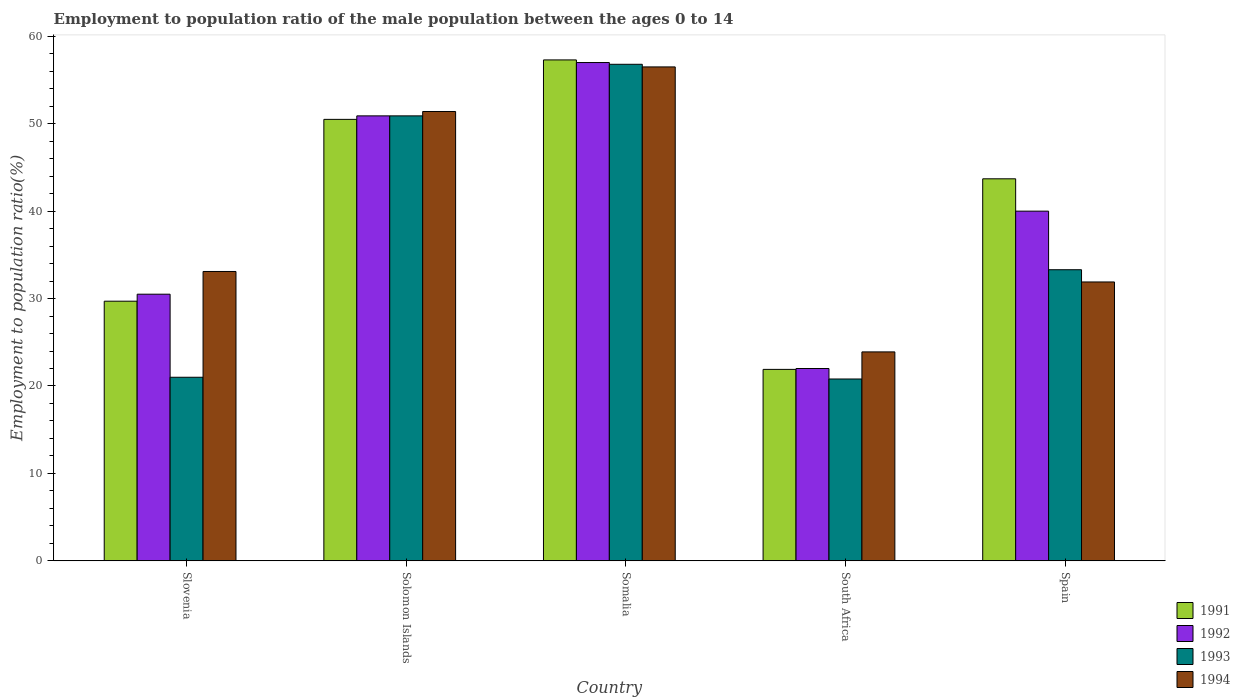How many groups of bars are there?
Provide a short and direct response. 5. Are the number of bars on each tick of the X-axis equal?
Your answer should be compact. Yes. How many bars are there on the 4th tick from the left?
Ensure brevity in your answer.  4. How many bars are there on the 2nd tick from the right?
Offer a terse response. 4. What is the employment to population ratio in 1991 in Spain?
Provide a short and direct response. 43.7. Across all countries, what is the maximum employment to population ratio in 1993?
Provide a succinct answer. 56.8. Across all countries, what is the minimum employment to population ratio in 1994?
Offer a terse response. 23.9. In which country was the employment to population ratio in 1992 maximum?
Provide a short and direct response. Somalia. In which country was the employment to population ratio in 1991 minimum?
Offer a very short reply. South Africa. What is the total employment to population ratio in 1994 in the graph?
Give a very brief answer. 196.8. What is the difference between the employment to population ratio in 1994 in Slovenia and that in Solomon Islands?
Offer a terse response. -18.3. What is the difference between the employment to population ratio in 1993 in Somalia and the employment to population ratio in 1991 in Slovenia?
Your answer should be very brief. 27.1. What is the average employment to population ratio in 1992 per country?
Offer a terse response. 40.08. What is the difference between the employment to population ratio of/in 1993 and employment to population ratio of/in 1991 in Spain?
Provide a short and direct response. -10.4. What is the ratio of the employment to population ratio in 1994 in Solomon Islands to that in South Africa?
Offer a terse response. 2.15. Is the difference between the employment to population ratio in 1993 in Slovenia and Somalia greater than the difference between the employment to population ratio in 1991 in Slovenia and Somalia?
Give a very brief answer. No. What is the difference between the highest and the second highest employment to population ratio in 1993?
Your response must be concise. 23.5. Is the sum of the employment to population ratio in 1991 in Solomon Islands and Somalia greater than the maximum employment to population ratio in 1994 across all countries?
Your response must be concise. Yes. Is it the case that in every country, the sum of the employment to population ratio in 1991 and employment to population ratio in 1993 is greater than the sum of employment to population ratio in 1992 and employment to population ratio in 1994?
Give a very brief answer. No. What does the 1st bar from the left in South Africa represents?
Offer a terse response. 1991. What does the 1st bar from the right in Somalia represents?
Your answer should be compact. 1994. How many bars are there?
Provide a succinct answer. 20. Does the graph contain any zero values?
Ensure brevity in your answer.  No. Where does the legend appear in the graph?
Give a very brief answer. Bottom right. What is the title of the graph?
Offer a terse response. Employment to population ratio of the male population between the ages 0 to 14. Does "1970" appear as one of the legend labels in the graph?
Provide a short and direct response. No. What is the Employment to population ratio(%) in 1991 in Slovenia?
Your answer should be very brief. 29.7. What is the Employment to population ratio(%) of 1992 in Slovenia?
Your answer should be very brief. 30.5. What is the Employment to population ratio(%) of 1994 in Slovenia?
Keep it short and to the point. 33.1. What is the Employment to population ratio(%) of 1991 in Solomon Islands?
Give a very brief answer. 50.5. What is the Employment to population ratio(%) in 1992 in Solomon Islands?
Keep it short and to the point. 50.9. What is the Employment to population ratio(%) in 1993 in Solomon Islands?
Ensure brevity in your answer.  50.9. What is the Employment to population ratio(%) of 1994 in Solomon Islands?
Offer a terse response. 51.4. What is the Employment to population ratio(%) of 1991 in Somalia?
Give a very brief answer. 57.3. What is the Employment to population ratio(%) of 1993 in Somalia?
Make the answer very short. 56.8. What is the Employment to population ratio(%) in 1994 in Somalia?
Ensure brevity in your answer.  56.5. What is the Employment to population ratio(%) in 1991 in South Africa?
Your answer should be compact. 21.9. What is the Employment to population ratio(%) of 1993 in South Africa?
Your response must be concise. 20.8. What is the Employment to population ratio(%) in 1994 in South Africa?
Your answer should be compact. 23.9. What is the Employment to population ratio(%) of 1991 in Spain?
Offer a terse response. 43.7. What is the Employment to population ratio(%) of 1993 in Spain?
Offer a very short reply. 33.3. What is the Employment to population ratio(%) in 1994 in Spain?
Ensure brevity in your answer.  31.9. Across all countries, what is the maximum Employment to population ratio(%) of 1991?
Your response must be concise. 57.3. Across all countries, what is the maximum Employment to population ratio(%) in 1992?
Your answer should be very brief. 57. Across all countries, what is the maximum Employment to population ratio(%) in 1993?
Give a very brief answer. 56.8. Across all countries, what is the maximum Employment to population ratio(%) in 1994?
Ensure brevity in your answer.  56.5. Across all countries, what is the minimum Employment to population ratio(%) in 1991?
Give a very brief answer. 21.9. Across all countries, what is the minimum Employment to population ratio(%) of 1992?
Your response must be concise. 22. Across all countries, what is the minimum Employment to population ratio(%) in 1993?
Make the answer very short. 20.8. Across all countries, what is the minimum Employment to population ratio(%) in 1994?
Your response must be concise. 23.9. What is the total Employment to population ratio(%) in 1991 in the graph?
Ensure brevity in your answer.  203.1. What is the total Employment to population ratio(%) of 1992 in the graph?
Make the answer very short. 200.4. What is the total Employment to population ratio(%) of 1993 in the graph?
Keep it short and to the point. 182.8. What is the total Employment to population ratio(%) in 1994 in the graph?
Keep it short and to the point. 196.8. What is the difference between the Employment to population ratio(%) of 1991 in Slovenia and that in Solomon Islands?
Provide a succinct answer. -20.8. What is the difference between the Employment to population ratio(%) of 1992 in Slovenia and that in Solomon Islands?
Your answer should be compact. -20.4. What is the difference between the Employment to population ratio(%) in 1993 in Slovenia and that in Solomon Islands?
Make the answer very short. -29.9. What is the difference between the Employment to population ratio(%) of 1994 in Slovenia and that in Solomon Islands?
Your answer should be compact. -18.3. What is the difference between the Employment to population ratio(%) of 1991 in Slovenia and that in Somalia?
Keep it short and to the point. -27.6. What is the difference between the Employment to population ratio(%) in 1992 in Slovenia and that in Somalia?
Your answer should be compact. -26.5. What is the difference between the Employment to population ratio(%) in 1993 in Slovenia and that in Somalia?
Provide a succinct answer. -35.8. What is the difference between the Employment to population ratio(%) in 1994 in Slovenia and that in Somalia?
Make the answer very short. -23.4. What is the difference between the Employment to population ratio(%) in 1991 in Slovenia and that in South Africa?
Ensure brevity in your answer.  7.8. What is the difference between the Employment to population ratio(%) in 1992 in Slovenia and that in South Africa?
Offer a very short reply. 8.5. What is the difference between the Employment to population ratio(%) in 1993 in Slovenia and that in South Africa?
Provide a succinct answer. 0.2. What is the difference between the Employment to population ratio(%) in 1994 in Slovenia and that in South Africa?
Your response must be concise. 9.2. What is the difference between the Employment to population ratio(%) of 1991 in Slovenia and that in Spain?
Your response must be concise. -14. What is the difference between the Employment to population ratio(%) of 1992 in Solomon Islands and that in Somalia?
Your answer should be compact. -6.1. What is the difference between the Employment to population ratio(%) in 1993 in Solomon Islands and that in Somalia?
Provide a short and direct response. -5.9. What is the difference between the Employment to population ratio(%) in 1991 in Solomon Islands and that in South Africa?
Offer a very short reply. 28.6. What is the difference between the Employment to population ratio(%) in 1992 in Solomon Islands and that in South Africa?
Provide a succinct answer. 28.9. What is the difference between the Employment to population ratio(%) in 1993 in Solomon Islands and that in South Africa?
Give a very brief answer. 30.1. What is the difference between the Employment to population ratio(%) in 1994 in Solomon Islands and that in South Africa?
Your response must be concise. 27.5. What is the difference between the Employment to population ratio(%) in 1993 in Solomon Islands and that in Spain?
Keep it short and to the point. 17.6. What is the difference between the Employment to population ratio(%) of 1991 in Somalia and that in South Africa?
Your answer should be very brief. 35.4. What is the difference between the Employment to population ratio(%) in 1992 in Somalia and that in South Africa?
Offer a terse response. 35. What is the difference between the Employment to population ratio(%) in 1994 in Somalia and that in South Africa?
Offer a very short reply. 32.6. What is the difference between the Employment to population ratio(%) of 1991 in Somalia and that in Spain?
Your answer should be compact. 13.6. What is the difference between the Employment to population ratio(%) of 1992 in Somalia and that in Spain?
Ensure brevity in your answer.  17. What is the difference between the Employment to population ratio(%) of 1994 in Somalia and that in Spain?
Provide a succinct answer. 24.6. What is the difference between the Employment to population ratio(%) of 1991 in South Africa and that in Spain?
Offer a very short reply. -21.8. What is the difference between the Employment to population ratio(%) in 1992 in South Africa and that in Spain?
Your answer should be compact. -18. What is the difference between the Employment to population ratio(%) in 1991 in Slovenia and the Employment to population ratio(%) in 1992 in Solomon Islands?
Ensure brevity in your answer.  -21.2. What is the difference between the Employment to population ratio(%) of 1991 in Slovenia and the Employment to population ratio(%) of 1993 in Solomon Islands?
Keep it short and to the point. -21.2. What is the difference between the Employment to population ratio(%) in 1991 in Slovenia and the Employment to population ratio(%) in 1994 in Solomon Islands?
Give a very brief answer. -21.7. What is the difference between the Employment to population ratio(%) of 1992 in Slovenia and the Employment to population ratio(%) of 1993 in Solomon Islands?
Your response must be concise. -20.4. What is the difference between the Employment to population ratio(%) in 1992 in Slovenia and the Employment to population ratio(%) in 1994 in Solomon Islands?
Provide a succinct answer. -20.9. What is the difference between the Employment to population ratio(%) of 1993 in Slovenia and the Employment to population ratio(%) of 1994 in Solomon Islands?
Your answer should be compact. -30.4. What is the difference between the Employment to population ratio(%) in 1991 in Slovenia and the Employment to population ratio(%) in 1992 in Somalia?
Your response must be concise. -27.3. What is the difference between the Employment to population ratio(%) in 1991 in Slovenia and the Employment to population ratio(%) in 1993 in Somalia?
Your answer should be very brief. -27.1. What is the difference between the Employment to population ratio(%) in 1991 in Slovenia and the Employment to population ratio(%) in 1994 in Somalia?
Offer a terse response. -26.8. What is the difference between the Employment to population ratio(%) in 1992 in Slovenia and the Employment to population ratio(%) in 1993 in Somalia?
Offer a terse response. -26.3. What is the difference between the Employment to population ratio(%) in 1992 in Slovenia and the Employment to population ratio(%) in 1994 in Somalia?
Offer a terse response. -26. What is the difference between the Employment to population ratio(%) of 1993 in Slovenia and the Employment to population ratio(%) of 1994 in Somalia?
Provide a short and direct response. -35.5. What is the difference between the Employment to population ratio(%) in 1991 in Slovenia and the Employment to population ratio(%) in 1992 in South Africa?
Keep it short and to the point. 7.7. What is the difference between the Employment to population ratio(%) in 1991 in Slovenia and the Employment to population ratio(%) in 1993 in South Africa?
Your response must be concise. 8.9. What is the difference between the Employment to population ratio(%) of 1991 in Slovenia and the Employment to population ratio(%) of 1994 in South Africa?
Ensure brevity in your answer.  5.8. What is the difference between the Employment to population ratio(%) in 1992 in Slovenia and the Employment to population ratio(%) in 1994 in South Africa?
Provide a succinct answer. 6.6. What is the difference between the Employment to population ratio(%) in 1991 in Slovenia and the Employment to population ratio(%) in 1992 in Spain?
Keep it short and to the point. -10.3. What is the difference between the Employment to population ratio(%) of 1992 in Slovenia and the Employment to population ratio(%) of 1993 in Spain?
Offer a very short reply. -2.8. What is the difference between the Employment to population ratio(%) in 1991 in Solomon Islands and the Employment to population ratio(%) in 1992 in Somalia?
Offer a very short reply. -6.5. What is the difference between the Employment to population ratio(%) of 1992 in Solomon Islands and the Employment to population ratio(%) of 1993 in Somalia?
Make the answer very short. -5.9. What is the difference between the Employment to population ratio(%) of 1993 in Solomon Islands and the Employment to population ratio(%) of 1994 in Somalia?
Provide a succinct answer. -5.6. What is the difference between the Employment to population ratio(%) in 1991 in Solomon Islands and the Employment to population ratio(%) in 1993 in South Africa?
Make the answer very short. 29.7. What is the difference between the Employment to population ratio(%) in 1991 in Solomon Islands and the Employment to population ratio(%) in 1994 in South Africa?
Offer a very short reply. 26.6. What is the difference between the Employment to population ratio(%) of 1992 in Solomon Islands and the Employment to population ratio(%) of 1993 in South Africa?
Keep it short and to the point. 30.1. What is the difference between the Employment to population ratio(%) of 1991 in Solomon Islands and the Employment to population ratio(%) of 1993 in Spain?
Provide a succinct answer. 17.2. What is the difference between the Employment to population ratio(%) in 1992 in Solomon Islands and the Employment to population ratio(%) in 1993 in Spain?
Keep it short and to the point. 17.6. What is the difference between the Employment to population ratio(%) in 1993 in Solomon Islands and the Employment to population ratio(%) in 1994 in Spain?
Keep it short and to the point. 19. What is the difference between the Employment to population ratio(%) of 1991 in Somalia and the Employment to population ratio(%) of 1992 in South Africa?
Offer a terse response. 35.3. What is the difference between the Employment to population ratio(%) of 1991 in Somalia and the Employment to population ratio(%) of 1993 in South Africa?
Make the answer very short. 36.5. What is the difference between the Employment to population ratio(%) of 1991 in Somalia and the Employment to population ratio(%) of 1994 in South Africa?
Make the answer very short. 33.4. What is the difference between the Employment to population ratio(%) in 1992 in Somalia and the Employment to population ratio(%) in 1993 in South Africa?
Offer a very short reply. 36.2. What is the difference between the Employment to population ratio(%) in 1992 in Somalia and the Employment to population ratio(%) in 1994 in South Africa?
Provide a succinct answer. 33.1. What is the difference between the Employment to population ratio(%) of 1993 in Somalia and the Employment to population ratio(%) of 1994 in South Africa?
Keep it short and to the point. 32.9. What is the difference between the Employment to population ratio(%) of 1991 in Somalia and the Employment to population ratio(%) of 1994 in Spain?
Your answer should be very brief. 25.4. What is the difference between the Employment to population ratio(%) in 1992 in Somalia and the Employment to population ratio(%) in 1993 in Spain?
Ensure brevity in your answer.  23.7. What is the difference between the Employment to population ratio(%) of 1992 in Somalia and the Employment to population ratio(%) of 1994 in Spain?
Give a very brief answer. 25.1. What is the difference between the Employment to population ratio(%) of 1993 in Somalia and the Employment to population ratio(%) of 1994 in Spain?
Provide a short and direct response. 24.9. What is the difference between the Employment to population ratio(%) of 1991 in South Africa and the Employment to population ratio(%) of 1992 in Spain?
Your response must be concise. -18.1. What is the difference between the Employment to population ratio(%) in 1991 in South Africa and the Employment to population ratio(%) in 1993 in Spain?
Your answer should be compact. -11.4. What is the difference between the Employment to population ratio(%) in 1991 in South Africa and the Employment to population ratio(%) in 1994 in Spain?
Your answer should be compact. -10. What is the average Employment to population ratio(%) in 1991 per country?
Your response must be concise. 40.62. What is the average Employment to population ratio(%) in 1992 per country?
Provide a succinct answer. 40.08. What is the average Employment to population ratio(%) of 1993 per country?
Your answer should be compact. 36.56. What is the average Employment to population ratio(%) of 1994 per country?
Ensure brevity in your answer.  39.36. What is the difference between the Employment to population ratio(%) in 1992 and Employment to population ratio(%) in 1993 in Slovenia?
Offer a terse response. 9.5. What is the difference between the Employment to population ratio(%) of 1992 and Employment to population ratio(%) of 1994 in Slovenia?
Your response must be concise. -2.6. What is the difference between the Employment to population ratio(%) of 1991 and Employment to population ratio(%) of 1992 in Solomon Islands?
Your answer should be very brief. -0.4. What is the difference between the Employment to population ratio(%) of 1991 and Employment to population ratio(%) of 1994 in Solomon Islands?
Offer a terse response. -0.9. What is the difference between the Employment to population ratio(%) of 1992 and Employment to population ratio(%) of 1993 in Solomon Islands?
Your answer should be compact. 0. What is the difference between the Employment to population ratio(%) in 1992 and Employment to population ratio(%) in 1994 in Solomon Islands?
Keep it short and to the point. -0.5. What is the difference between the Employment to population ratio(%) of 1991 and Employment to population ratio(%) of 1992 in Somalia?
Provide a short and direct response. 0.3. What is the difference between the Employment to population ratio(%) of 1991 and Employment to population ratio(%) of 1993 in Somalia?
Provide a short and direct response. 0.5. What is the difference between the Employment to population ratio(%) in 1991 and Employment to population ratio(%) in 1992 in South Africa?
Give a very brief answer. -0.1. What is the difference between the Employment to population ratio(%) of 1991 and Employment to population ratio(%) of 1993 in South Africa?
Give a very brief answer. 1.1. What is the difference between the Employment to population ratio(%) in 1991 and Employment to population ratio(%) in 1994 in South Africa?
Offer a terse response. -2. What is the difference between the Employment to population ratio(%) of 1992 and Employment to population ratio(%) of 1994 in South Africa?
Your answer should be very brief. -1.9. What is the difference between the Employment to population ratio(%) of 1991 and Employment to population ratio(%) of 1992 in Spain?
Keep it short and to the point. 3.7. What is the difference between the Employment to population ratio(%) of 1991 and Employment to population ratio(%) of 1994 in Spain?
Your response must be concise. 11.8. What is the difference between the Employment to population ratio(%) of 1992 and Employment to population ratio(%) of 1994 in Spain?
Make the answer very short. 8.1. What is the difference between the Employment to population ratio(%) in 1993 and Employment to population ratio(%) in 1994 in Spain?
Offer a very short reply. 1.4. What is the ratio of the Employment to population ratio(%) in 1991 in Slovenia to that in Solomon Islands?
Provide a succinct answer. 0.59. What is the ratio of the Employment to population ratio(%) of 1992 in Slovenia to that in Solomon Islands?
Give a very brief answer. 0.6. What is the ratio of the Employment to population ratio(%) in 1993 in Slovenia to that in Solomon Islands?
Your answer should be very brief. 0.41. What is the ratio of the Employment to population ratio(%) in 1994 in Slovenia to that in Solomon Islands?
Your answer should be compact. 0.64. What is the ratio of the Employment to population ratio(%) of 1991 in Slovenia to that in Somalia?
Keep it short and to the point. 0.52. What is the ratio of the Employment to population ratio(%) in 1992 in Slovenia to that in Somalia?
Your answer should be very brief. 0.54. What is the ratio of the Employment to population ratio(%) of 1993 in Slovenia to that in Somalia?
Your answer should be very brief. 0.37. What is the ratio of the Employment to population ratio(%) in 1994 in Slovenia to that in Somalia?
Your answer should be very brief. 0.59. What is the ratio of the Employment to population ratio(%) of 1991 in Slovenia to that in South Africa?
Offer a terse response. 1.36. What is the ratio of the Employment to population ratio(%) in 1992 in Slovenia to that in South Africa?
Your answer should be very brief. 1.39. What is the ratio of the Employment to population ratio(%) of 1993 in Slovenia to that in South Africa?
Offer a terse response. 1.01. What is the ratio of the Employment to population ratio(%) in 1994 in Slovenia to that in South Africa?
Ensure brevity in your answer.  1.38. What is the ratio of the Employment to population ratio(%) in 1991 in Slovenia to that in Spain?
Provide a short and direct response. 0.68. What is the ratio of the Employment to population ratio(%) in 1992 in Slovenia to that in Spain?
Make the answer very short. 0.76. What is the ratio of the Employment to population ratio(%) of 1993 in Slovenia to that in Spain?
Ensure brevity in your answer.  0.63. What is the ratio of the Employment to population ratio(%) of 1994 in Slovenia to that in Spain?
Ensure brevity in your answer.  1.04. What is the ratio of the Employment to population ratio(%) of 1991 in Solomon Islands to that in Somalia?
Ensure brevity in your answer.  0.88. What is the ratio of the Employment to population ratio(%) in 1992 in Solomon Islands to that in Somalia?
Your answer should be compact. 0.89. What is the ratio of the Employment to population ratio(%) of 1993 in Solomon Islands to that in Somalia?
Provide a short and direct response. 0.9. What is the ratio of the Employment to population ratio(%) in 1994 in Solomon Islands to that in Somalia?
Offer a terse response. 0.91. What is the ratio of the Employment to population ratio(%) in 1991 in Solomon Islands to that in South Africa?
Your answer should be very brief. 2.31. What is the ratio of the Employment to population ratio(%) in 1992 in Solomon Islands to that in South Africa?
Keep it short and to the point. 2.31. What is the ratio of the Employment to population ratio(%) of 1993 in Solomon Islands to that in South Africa?
Ensure brevity in your answer.  2.45. What is the ratio of the Employment to population ratio(%) in 1994 in Solomon Islands to that in South Africa?
Give a very brief answer. 2.15. What is the ratio of the Employment to population ratio(%) of 1991 in Solomon Islands to that in Spain?
Your answer should be compact. 1.16. What is the ratio of the Employment to population ratio(%) in 1992 in Solomon Islands to that in Spain?
Keep it short and to the point. 1.27. What is the ratio of the Employment to population ratio(%) in 1993 in Solomon Islands to that in Spain?
Your answer should be compact. 1.53. What is the ratio of the Employment to population ratio(%) in 1994 in Solomon Islands to that in Spain?
Your response must be concise. 1.61. What is the ratio of the Employment to population ratio(%) of 1991 in Somalia to that in South Africa?
Offer a terse response. 2.62. What is the ratio of the Employment to population ratio(%) in 1992 in Somalia to that in South Africa?
Ensure brevity in your answer.  2.59. What is the ratio of the Employment to population ratio(%) of 1993 in Somalia to that in South Africa?
Ensure brevity in your answer.  2.73. What is the ratio of the Employment to population ratio(%) in 1994 in Somalia to that in South Africa?
Your answer should be very brief. 2.36. What is the ratio of the Employment to population ratio(%) in 1991 in Somalia to that in Spain?
Your answer should be very brief. 1.31. What is the ratio of the Employment to population ratio(%) in 1992 in Somalia to that in Spain?
Provide a succinct answer. 1.43. What is the ratio of the Employment to population ratio(%) of 1993 in Somalia to that in Spain?
Make the answer very short. 1.71. What is the ratio of the Employment to population ratio(%) in 1994 in Somalia to that in Spain?
Provide a succinct answer. 1.77. What is the ratio of the Employment to population ratio(%) of 1991 in South Africa to that in Spain?
Your answer should be very brief. 0.5. What is the ratio of the Employment to population ratio(%) in 1992 in South Africa to that in Spain?
Your answer should be very brief. 0.55. What is the ratio of the Employment to population ratio(%) in 1993 in South Africa to that in Spain?
Your response must be concise. 0.62. What is the ratio of the Employment to population ratio(%) of 1994 in South Africa to that in Spain?
Make the answer very short. 0.75. What is the difference between the highest and the second highest Employment to population ratio(%) in 1991?
Offer a very short reply. 6.8. What is the difference between the highest and the second highest Employment to population ratio(%) in 1994?
Give a very brief answer. 5.1. What is the difference between the highest and the lowest Employment to population ratio(%) in 1991?
Your response must be concise. 35.4. What is the difference between the highest and the lowest Employment to population ratio(%) in 1992?
Give a very brief answer. 35. What is the difference between the highest and the lowest Employment to population ratio(%) of 1994?
Offer a very short reply. 32.6. 